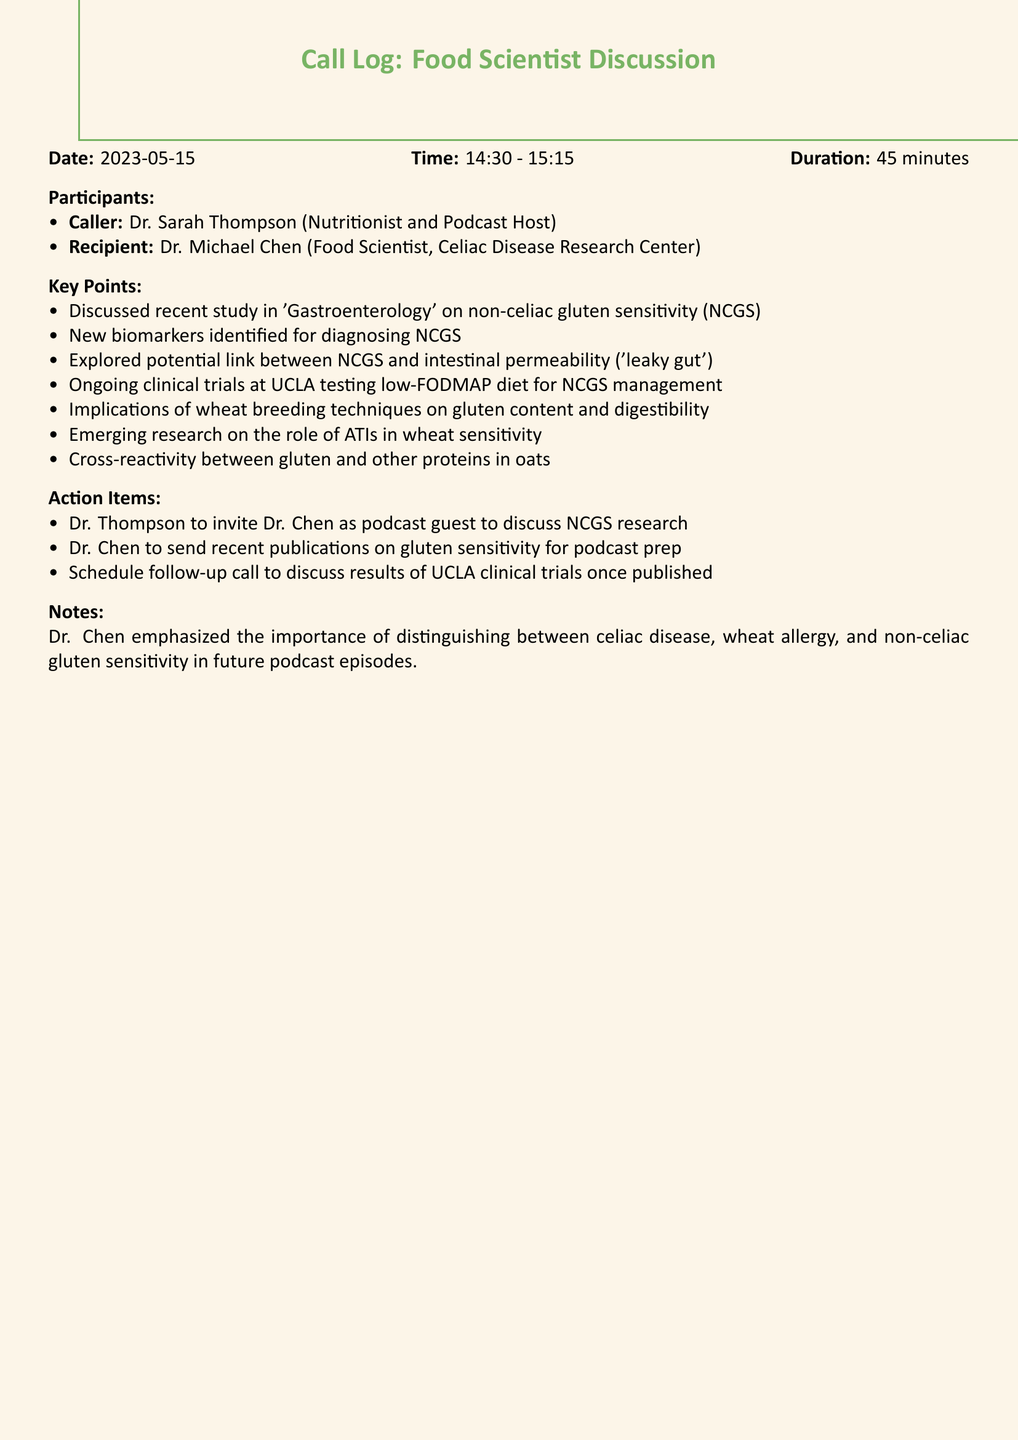what is the date of the call? The date of the call is specified in the document header as when the discussion occurred.
Answer: 2023-05-15 who is the caller? The caller is identified at the beginning of the document, providing the name of the person initiating the call.
Answer: Dr. Sarah Thompson what is the duration of the call? The duration of the call is provided in the document, which indicates how long the conversation lasted.
Answer: 45 minutes what was one of the key points discussed? Key points from the discussion are listed, reflecting the important topics covered during the call.
Answer: New biomarkers identified for diagnosing NCGS who is the recipient of the call? The recipient of the call is named at the beginning of the call log, indicating who was on the receiving end of the conversation.
Answer: Dr. Michael Chen what action item involves the podcast? Action items are listed, highlighting tasks to be completed following the call, specifically related to the podcast.
Answer: Dr. Thompson to invite Dr. Chen as podcast guest what is the focus of the clinical trials mentioned? The clinical trials noted in the document focus on a specific dietary approach for managing a condition, which is discussed.
Answer: low-FODMAP diet for NCGS management what topic should future podcast episodes distinguish? The document mentions specific conditions that need to be differentiated in future discussions, reflecting the importance of clarity in topics.
Answer: celiac disease, wheat allergy, and non-celiac gluten sensitivity what is the time of the call? The exact time of the call is given in the document, specifying when the conversation took place.
Answer: 14:30 - 15:15 